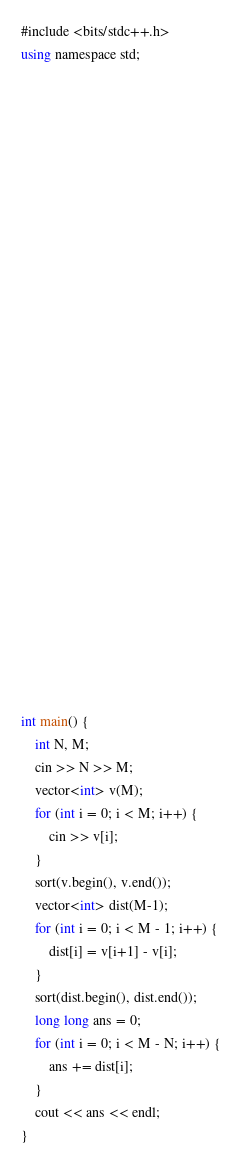Convert code to text. <code><loc_0><loc_0><loc_500><loc_500><_C#_>#include <bits/stdc++.h>
using namespace std;




























int main() {
    int N, M;
    cin >> N >> M;
    vector<int> v(M);
    for (int i = 0; i < M; i++) {
        cin >> v[i];
    }
    sort(v.begin(), v.end());
    vector<int> dist(M-1);
    for (int i = 0; i < M - 1; i++) {
        dist[i] = v[i+1] - v[i];
    }
    sort(dist.begin(), dist.end());
    long long ans = 0;
    for (int i = 0; i < M - N; i++) {
        ans += dist[i];
    }
    cout << ans << endl;
}</code> 